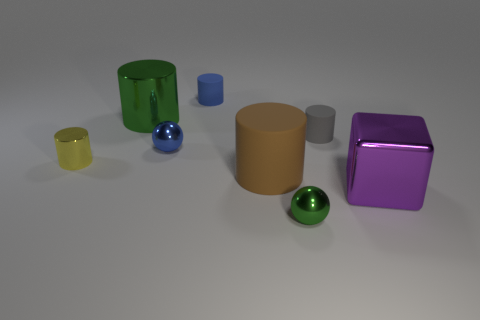Subtract 2 cylinders. How many cylinders are left? 3 Subtract all small blue rubber cylinders. How many cylinders are left? 4 Subtract all brown cylinders. How many cylinders are left? 4 Add 2 tiny yellow cylinders. How many objects exist? 10 Subtract all blue cylinders. Subtract all purple balls. How many cylinders are left? 4 Subtract all blocks. How many objects are left? 7 Add 7 small blue balls. How many small blue balls are left? 8 Add 5 red rubber blocks. How many red rubber blocks exist? 5 Subtract 0 blue blocks. How many objects are left? 8 Subtract all green cylinders. Subtract all large brown things. How many objects are left? 6 